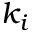Convert formula to latex. <formula><loc_0><loc_0><loc_500><loc_500>k _ { i }</formula> 